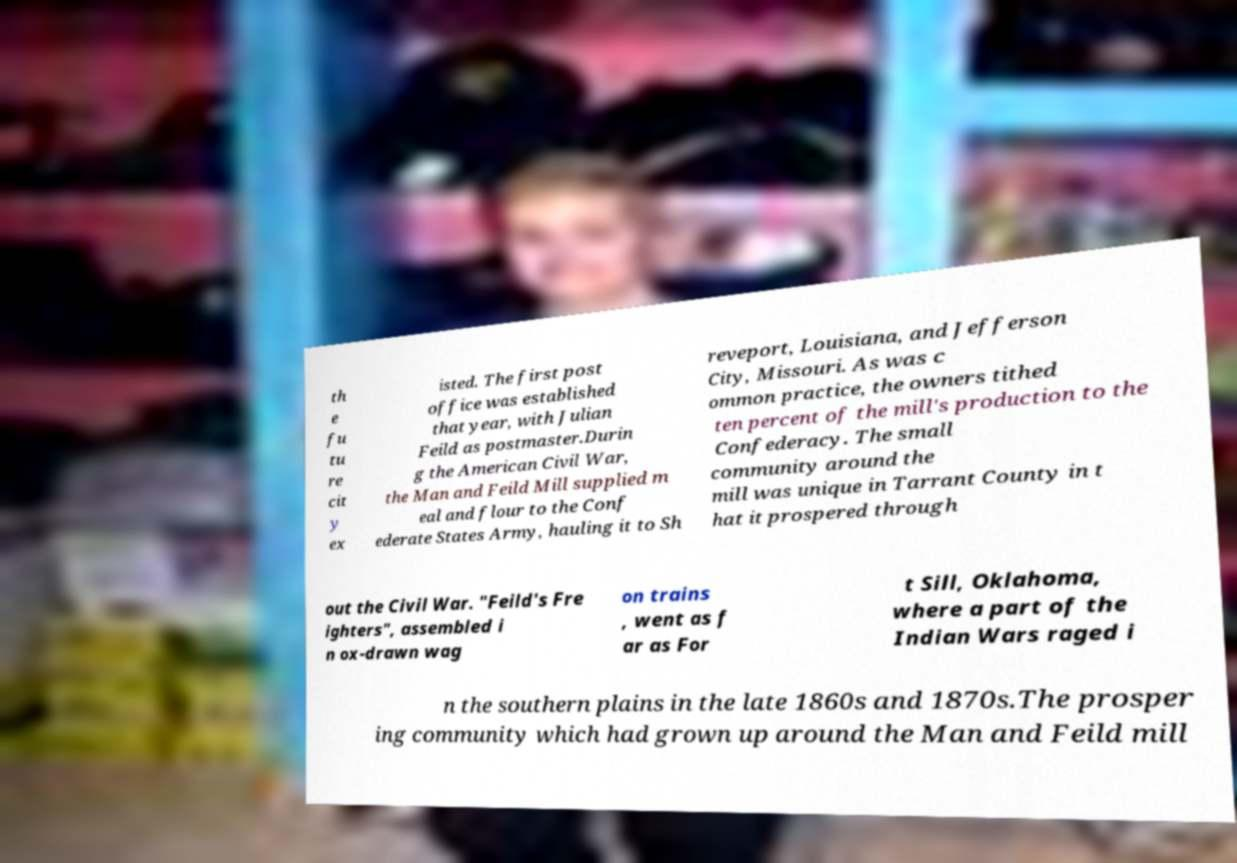Could you assist in decoding the text presented in this image and type it out clearly? th e fu tu re cit y ex isted. The first post office was established that year, with Julian Feild as postmaster.Durin g the American Civil War, the Man and Feild Mill supplied m eal and flour to the Conf ederate States Army, hauling it to Sh reveport, Louisiana, and Jefferson City, Missouri. As was c ommon practice, the owners tithed ten percent of the mill's production to the Confederacy. The small community around the mill was unique in Tarrant County in t hat it prospered through out the Civil War. "Feild's Fre ighters", assembled i n ox-drawn wag on trains , went as f ar as For t Sill, Oklahoma, where a part of the Indian Wars raged i n the southern plains in the late 1860s and 1870s.The prosper ing community which had grown up around the Man and Feild mill 